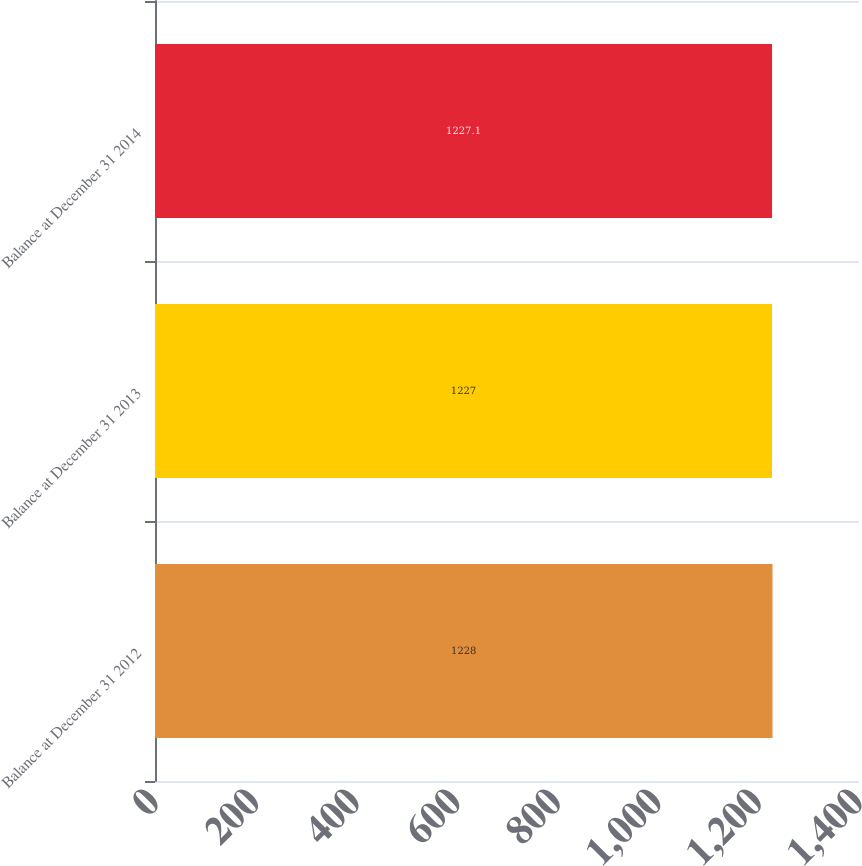Convert chart. <chart><loc_0><loc_0><loc_500><loc_500><bar_chart><fcel>Balance at December 31 2012<fcel>Balance at December 31 2013<fcel>Balance at December 31 2014<nl><fcel>1228<fcel>1227<fcel>1227.1<nl></chart> 